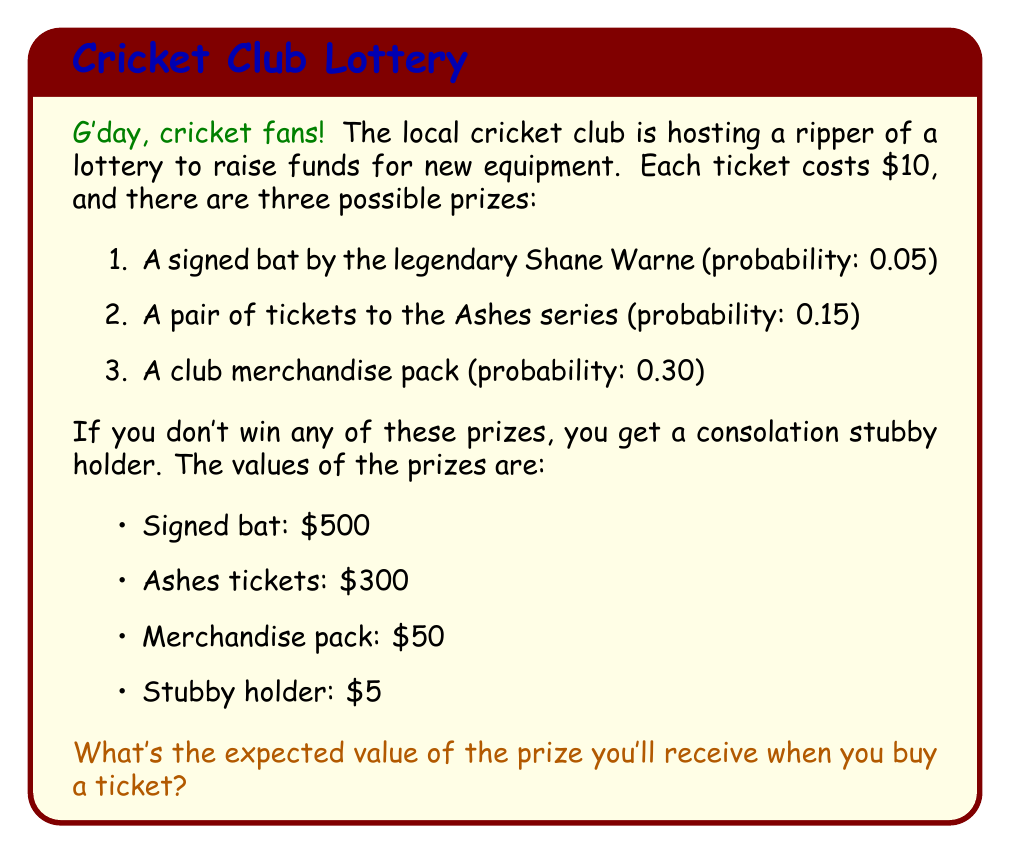Can you solve this math problem? Let's tackle this step by step, mate:

1) First, we need to identify our random variable. In this case, it's the value of the prize received, which we'll call $X$.

2) To calculate the expected value, we use the formula:

   $$E(X) = \sum_{i=1}^n x_i \cdot p(x_i)$$

   Where $x_i$ are the possible values and $p(x_i)$ are their respective probabilities.

3) Let's list out our values and probabilities:

   - Signed bat: $x_1 = 500$, $p(x_1) = 0.05$
   - Ashes tickets: $x_2 = 300$, $p(x_2) = 0.15$
   - Merchandise pack: $x_3 = 50$, $p(x_3) = 0.30$
   - Stubby holder: $x_4 = 5$, $p(x_4) = 1 - (0.05 + 0.15 + 0.30) = 0.50$

4) Now, let's plug these into our expected value formula:

   $$E(X) = 500 \cdot 0.05 + 300 \cdot 0.15 + 50 \cdot 0.30 + 5 \cdot 0.50$$

5) Let's calculate each term:

   $$E(X) = 25 + 45 + 15 + 2.50 = 87.50$$

Therefore, the expected value of the prize is $87.50.

6) However, remember that the ticket costs $10. To find the expected net value, we need to subtract this cost:

   $$\text{Expected Net Value} = 87.50 - 10 = 77.50$$
Answer: The expected value of the prize when you buy a ticket is $87.50, and the expected net value (after subtracting the ticket cost) is $77.50. 